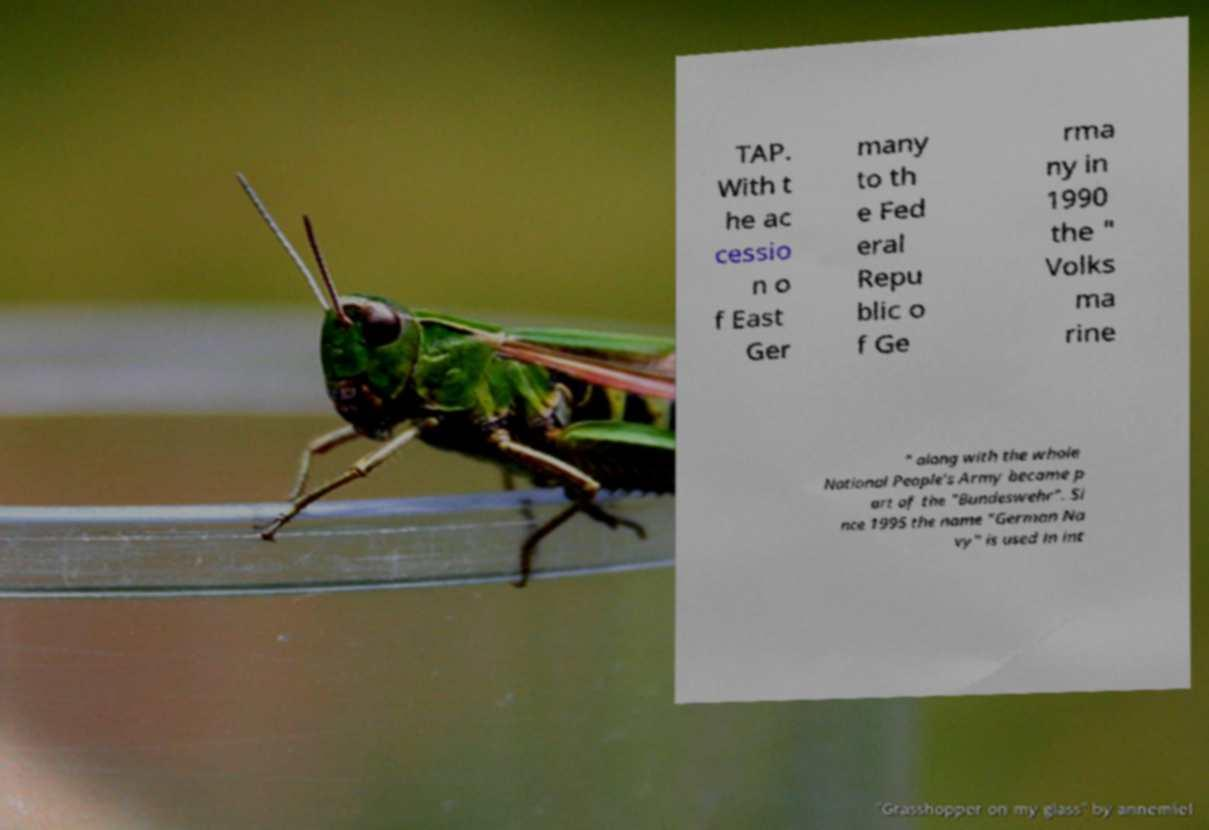Please identify and transcribe the text found in this image. TAP. With t he ac cessio n o f East Ger many to th e Fed eral Repu blic o f Ge rma ny in 1990 the " Volks ma rine " along with the whole National People's Army became p art of the "Bundeswehr". Si nce 1995 the name "German Na vy" is used in int 